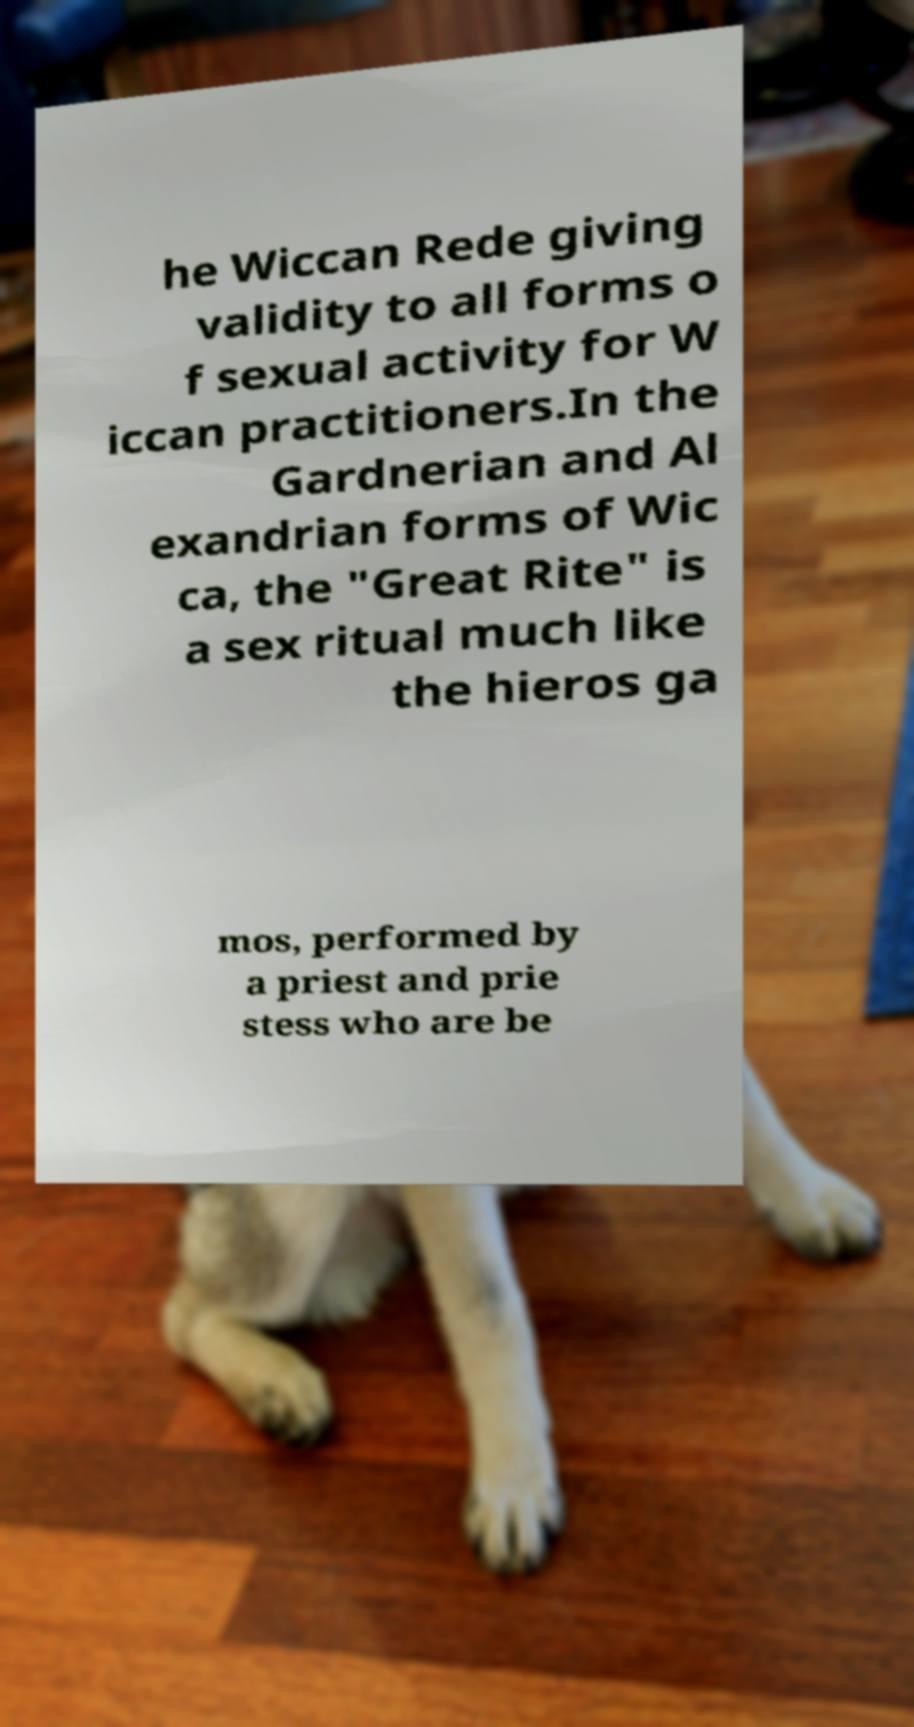Please identify and transcribe the text found in this image. he Wiccan Rede giving validity to all forms o f sexual activity for W iccan practitioners.In the Gardnerian and Al exandrian forms of Wic ca, the "Great Rite" is a sex ritual much like the hieros ga mos, performed by a priest and prie stess who are be 